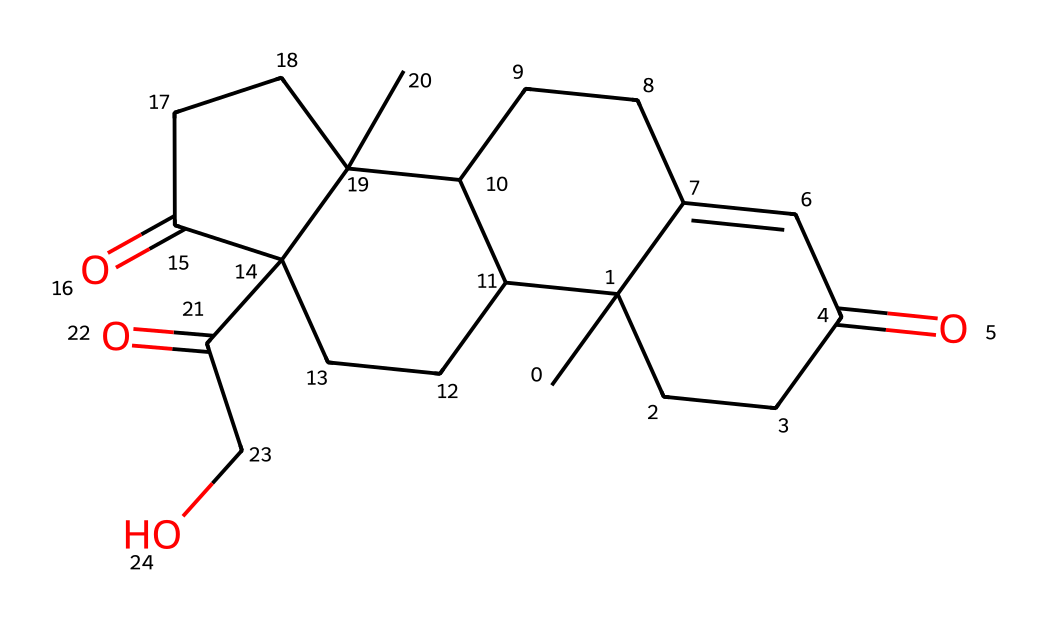What is the molecular formula of cortisol? To determine the molecular formula from the SMILES representation, we identify the elements and their respective counts. The SMILES contains multiple carbons (C) and some oxygens (O), and through careful analysis of the structure, we can determine the total count for each element. The molecular formula is C21H30O5.
Answer: C21H30O5 How many rings are present in the structure of cortisol? By analyzing the structural representation in the SMILES, we can see that the chemical has a complex fused ring system. Counting the interconnected rings leads to a clear conclusion that there are four rings present in the structure of cortisol.
Answer: 4 What type of functional groups are present in cortisol? The structure includes ketone groups indicated by the C(=O) notations. Additionally, there's also a hydroxyl group denoted by the presence of -OH for its functional representation. Thus, the main functional groups are ketone and hydroxyl.
Answer: ketone and hydroxyl What is the role of cortisol in the human body? Cortisol plays a crucial role as a steroid hormone that helps regulate metabolism, immune response, and stress. Its primary function is to manage how the body responds to stress and maintain homeostasis, affecting various physiological processes.
Answer: stress hormone How many hydroxyl groups are in the cortisol structure? To determine the number of hydroxyl groups in cortisol, we look for the -OH functional groups indicated in its structure. Inspecting the SMILES representation reveals there is one hydroxyl group present in cortisol.
Answer: 1 What is the molecular weight of cortisol? The molecular weight can be calculated based on the molecular formula C21H30O5. By summing the atomic weights of each constituent atom, we find that the molecular weight of cortisol is approximately 362.46 g/mol.
Answer: 362.46 g/mol What is the significance of the presence of oxygen in cortisol? The presence of oxygen is critical in cortisol as both ketone and hydroxyl functional groups impart properties such as solubility, reactivity, and biological activity in the context of hormone functionality and metabolism regulation.
Answer: biological activity 